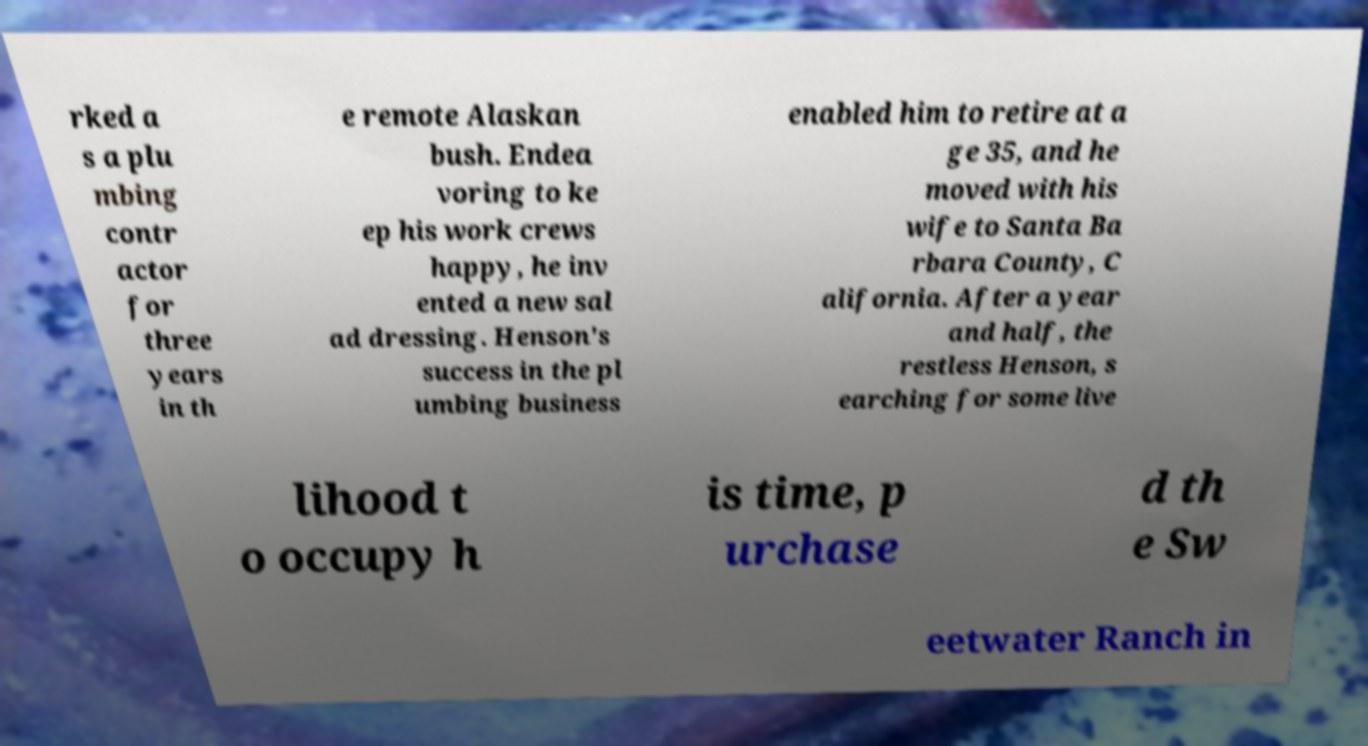Could you assist in decoding the text presented in this image and type it out clearly? rked a s a plu mbing contr actor for three years in th e remote Alaskan bush. Endea voring to ke ep his work crews happy, he inv ented a new sal ad dressing. Henson's success in the pl umbing business enabled him to retire at a ge 35, and he moved with his wife to Santa Ba rbara County, C alifornia. After a year and half, the restless Henson, s earching for some live lihood t o occupy h is time, p urchase d th e Sw eetwater Ranch in 